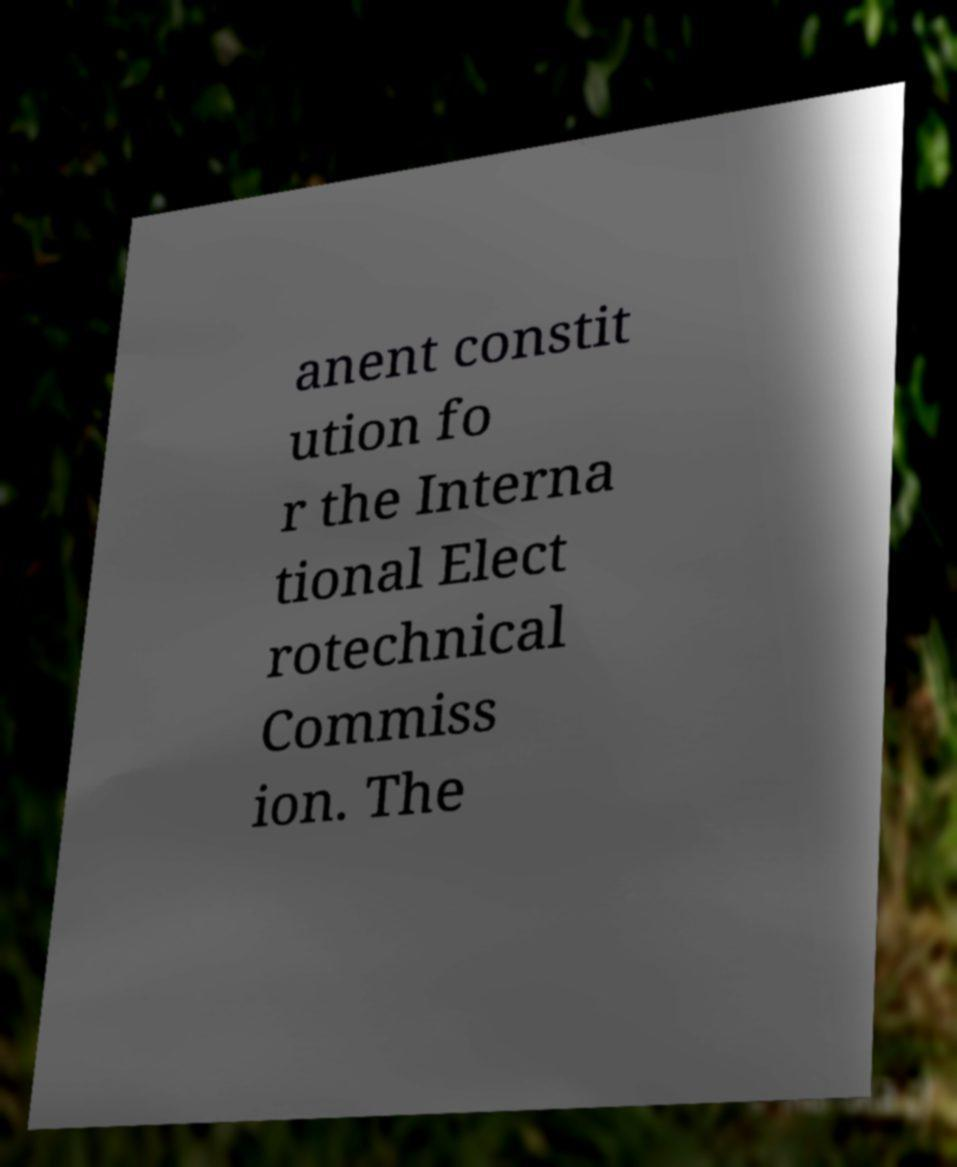Could you assist in decoding the text presented in this image and type it out clearly? anent constit ution fo r the Interna tional Elect rotechnical Commiss ion. The 